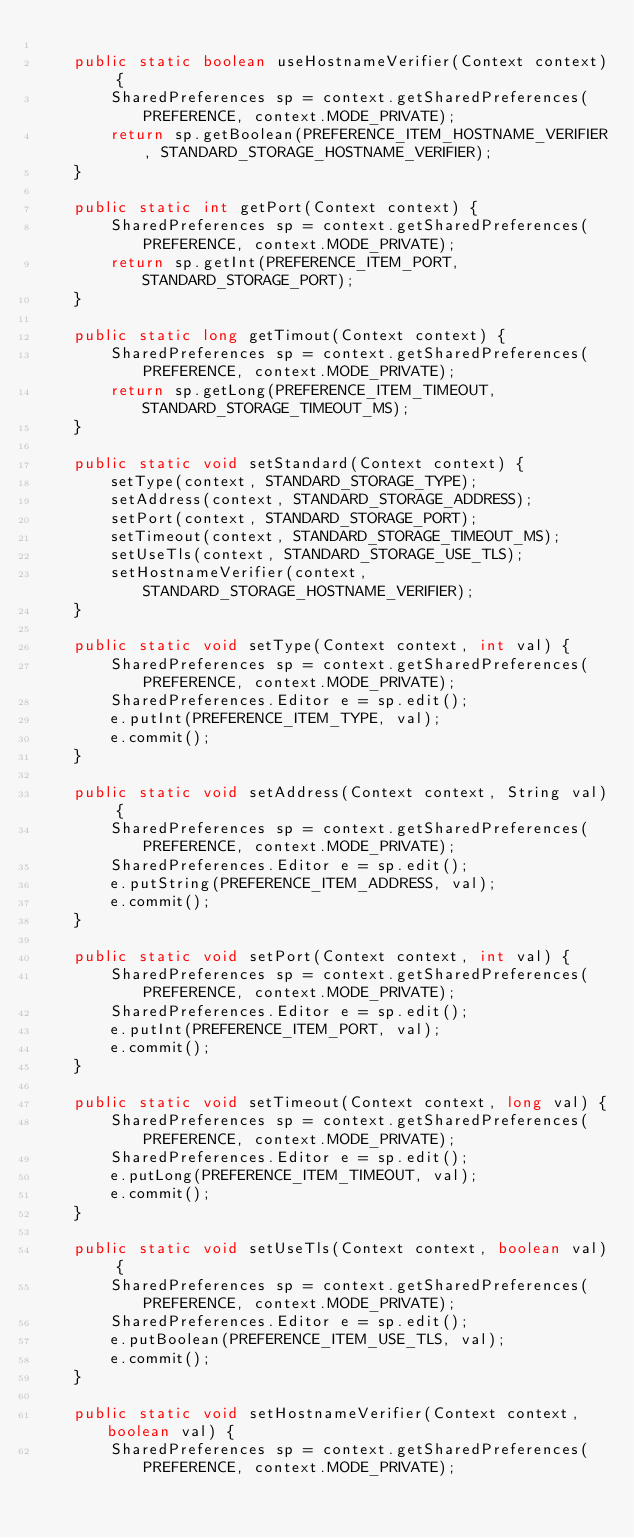Convert code to text. <code><loc_0><loc_0><loc_500><loc_500><_Java_>
    public static boolean useHostnameVerifier(Context context) {
        SharedPreferences sp = context.getSharedPreferences(PREFERENCE, context.MODE_PRIVATE);
        return sp.getBoolean(PREFERENCE_ITEM_HOSTNAME_VERIFIER, STANDARD_STORAGE_HOSTNAME_VERIFIER);
    }

    public static int getPort(Context context) {
        SharedPreferences sp = context.getSharedPreferences(PREFERENCE, context.MODE_PRIVATE);
        return sp.getInt(PREFERENCE_ITEM_PORT, STANDARD_STORAGE_PORT);
    }

    public static long getTimout(Context context) {
        SharedPreferences sp = context.getSharedPreferences(PREFERENCE, context.MODE_PRIVATE);
        return sp.getLong(PREFERENCE_ITEM_TIMEOUT, STANDARD_STORAGE_TIMEOUT_MS);
    }

    public static void setStandard(Context context) {
        setType(context, STANDARD_STORAGE_TYPE);
        setAddress(context, STANDARD_STORAGE_ADDRESS);
        setPort(context, STANDARD_STORAGE_PORT);
        setTimeout(context, STANDARD_STORAGE_TIMEOUT_MS);
        setUseTls(context, STANDARD_STORAGE_USE_TLS);
        setHostnameVerifier(context, STANDARD_STORAGE_HOSTNAME_VERIFIER);
    }

    public static void setType(Context context, int val) {
        SharedPreferences sp = context.getSharedPreferences(PREFERENCE, context.MODE_PRIVATE);
        SharedPreferences.Editor e = sp.edit();
        e.putInt(PREFERENCE_ITEM_TYPE, val);
        e.commit();
    }

    public static void setAddress(Context context, String val) {
        SharedPreferences sp = context.getSharedPreferences(PREFERENCE, context.MODE_PRIVATE);
        SharedPreferences.Editor e = sp.edit();
        e.putString(PREFERENCE_ITEM_ADDRESS, val);
        e.commit();
    }

    public static void setPort(Context context, int val) {
        SharedPreferences sp = context.getSharedPreferences(PREFERENCE, context.MODE_PRIVATE);
        SharedPreferences.Editor e = sp.edit();
        e.putInt(PREFERENCE_ITEM_PORT, val);
        e.commit();
    }

    public static void setTimeout(Context context, long val) {
        SharedPreferences sp = context.getSharedPreferences(PREFERENCE, context.MODE_PRIVATE);
        SharedPreferences.Editor e = sp.edit();
        e.putLong(PREFERENCE_ITEM_TIMEOUT, val);
        e.commit();
    }

    public static void setUseTls(Context context, boolean val) {
        SharedPreferences sp = context.getSharedPreferences(PREFERENCE, context.MODE_PRIVATE);
        SharedPreferences.Editor e = sp.edit();
        e.putBoolean(PREFERENCE_ITEM_USE_TLS, val);
        e.commit();
    }

    public static void setHostnameVerifier(Context context, boolean val) {
        SharedPreferences sp = context.getSharedPreferences(PREFERENCE, context.MODE_PRIVATE);</code> 